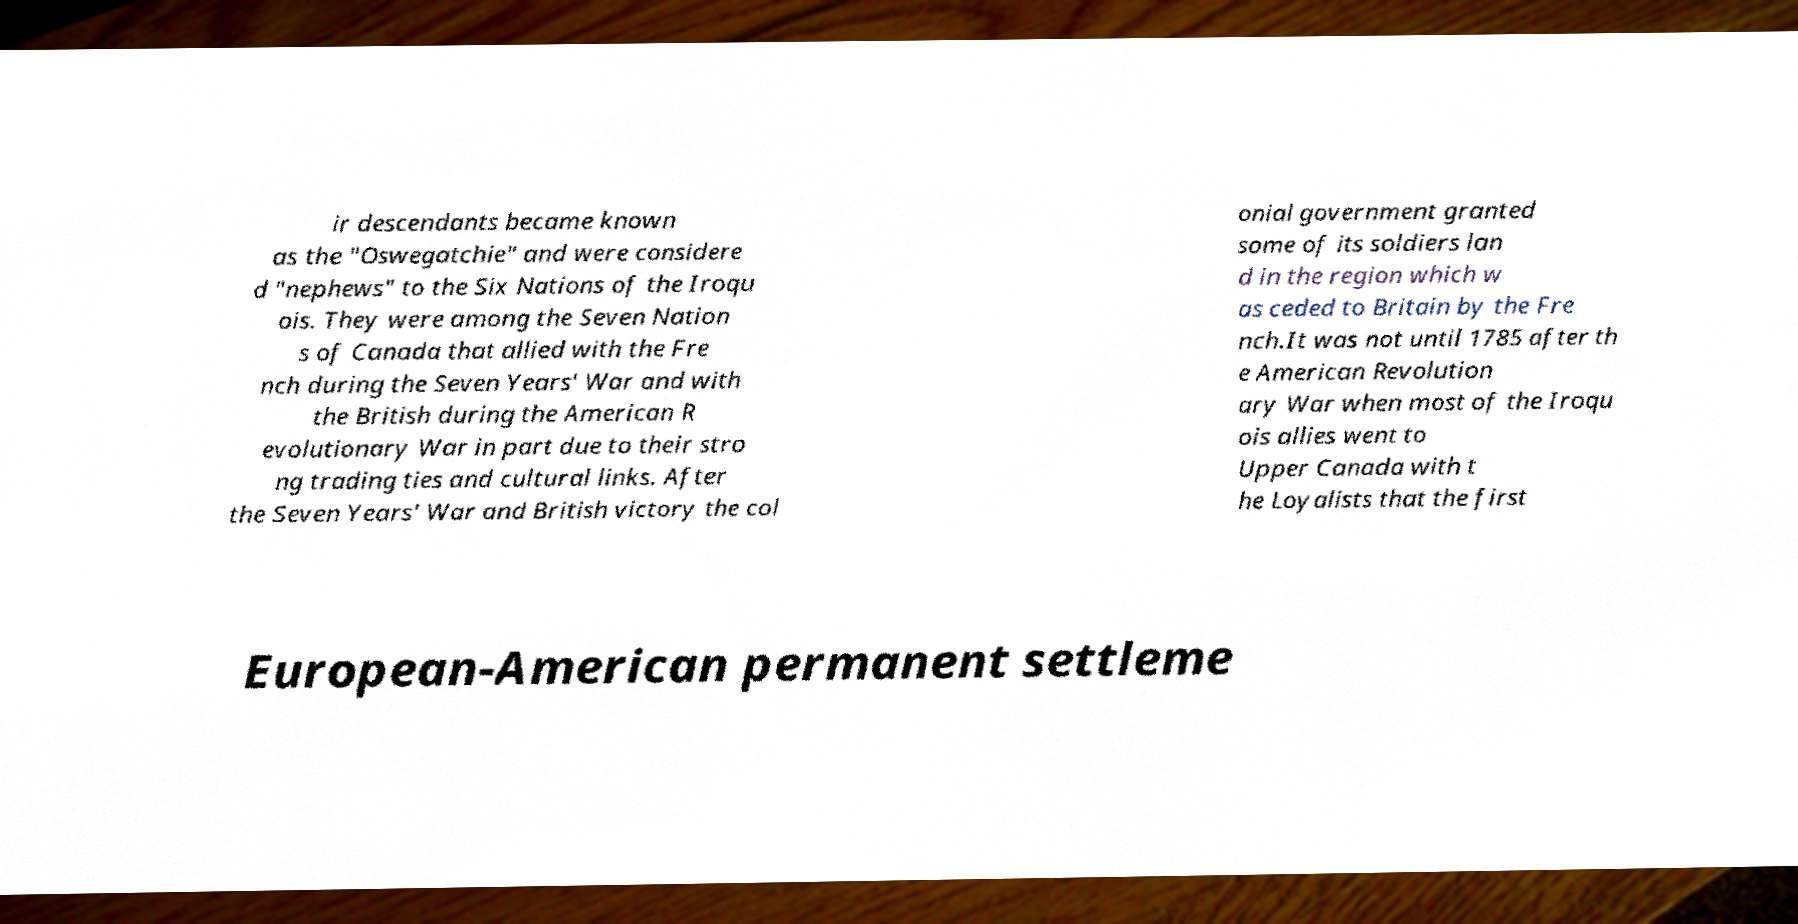What messages or text are displayed in this image? I need them in a readable, typed format. ir descendants became known as the "Oswegatchie" and were considere d "nephews" to the Six Nations of the Iroqu ois. They were among the Seven Nation s of Canada that allied with the Fre nch during the Seven Years' War and with the British during the American R evolutionary War in part due to their stro ng trading ties and cultural links. After the Seven Years' War and British victory the col onial government granted some of its soldiers lan d in the region which w as ceded to Britain by the Fre nch.It was not until 1785 after th e American Revolution ary War when most of the Iroqu ois allies went to Upper Canada with t he Loyalists that the first European-American permanent settleme 